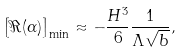Convert formula to latex. <formula><loc_0><loc_0><loc_500><loc_500>\left [ \Re ( \alpha ) \right ] _ { \min } \approx - \frac { H ^ { 3 } } { 6 } \frac { 1 } { \Lambda \sqrt { b } } ,</formula> 